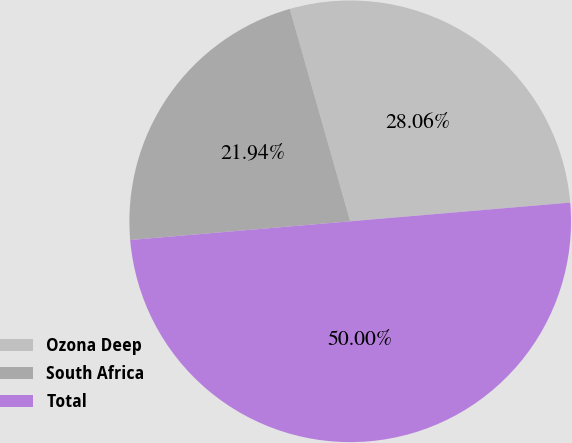<chart> <loc_0><loc_0><loc_500><loc_500><pie_chart><fcel>Ozona Deep<fcel>South Africa<fcel>Total<nl><fcel>28.06%<fcel>21.94%<fcel>50.0%<nl></chart> 